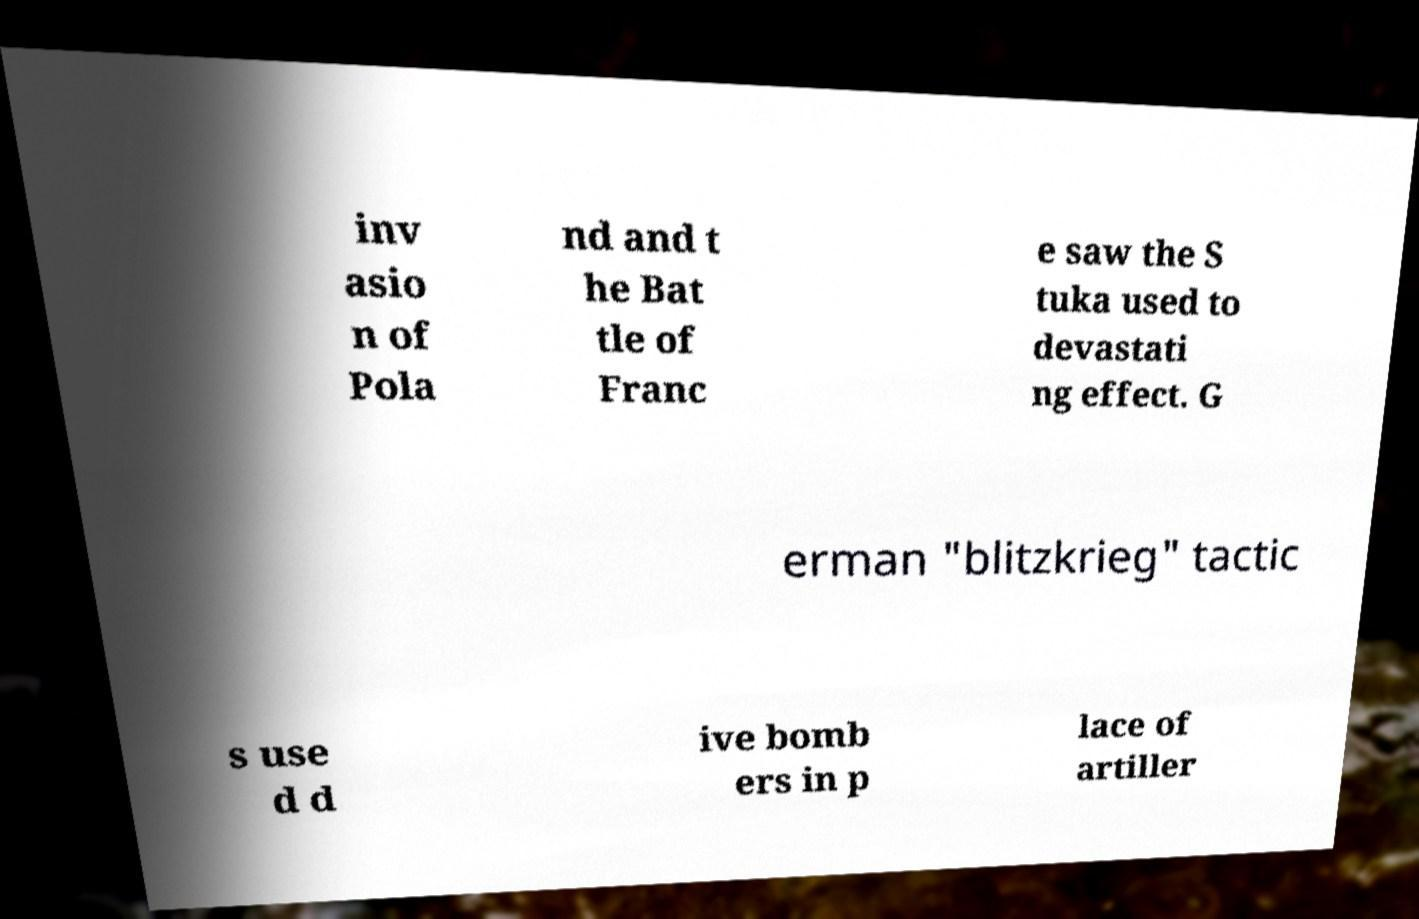Can you read and provide the text displayed in the image?This photo seems to have some interesting text. Can you extract and type it out for me? inv asio n of Pola nd and t he Bat tle of Franc e saw the S tuka used to devastati ng effect. G erman "blitzkrieg" tactic s use d d ive bomb ers in p lace of artiller 